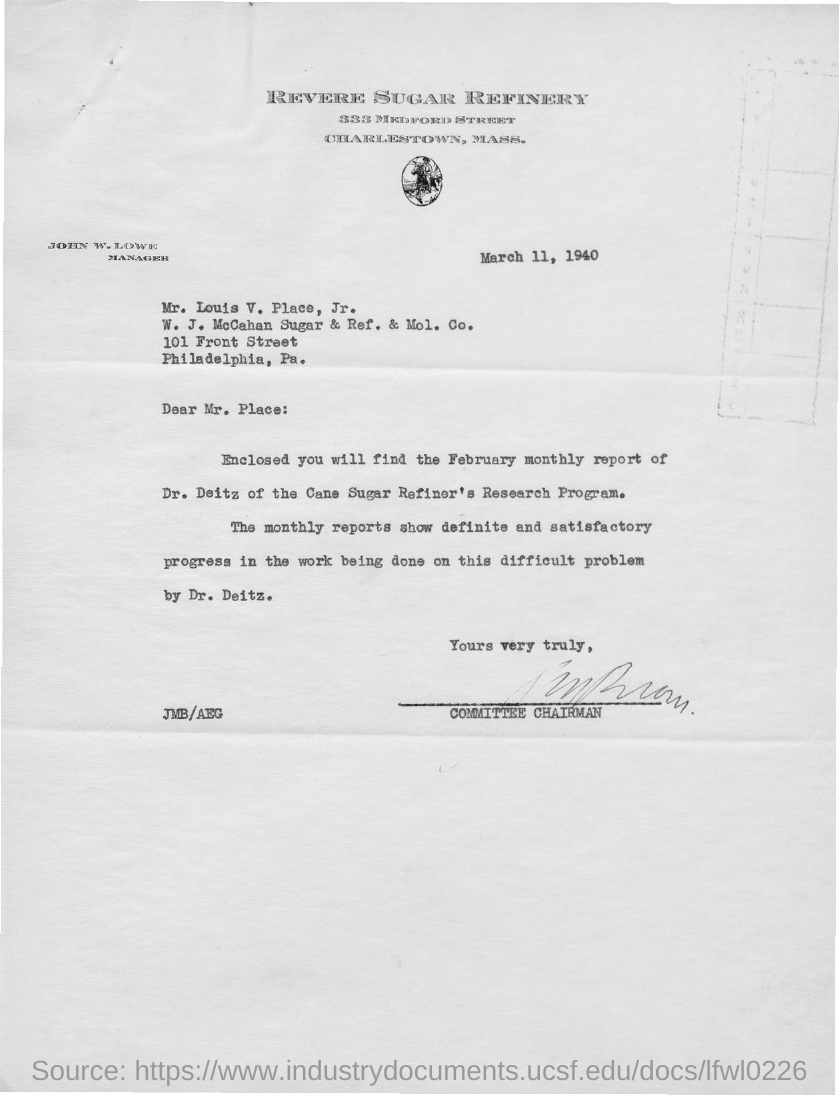Indicate a few pertinent items in this graphic. The letter is addressed to Mr. Place. The report enclosed is from Dr. Deitz. The date on the document is March 11, 1940. 